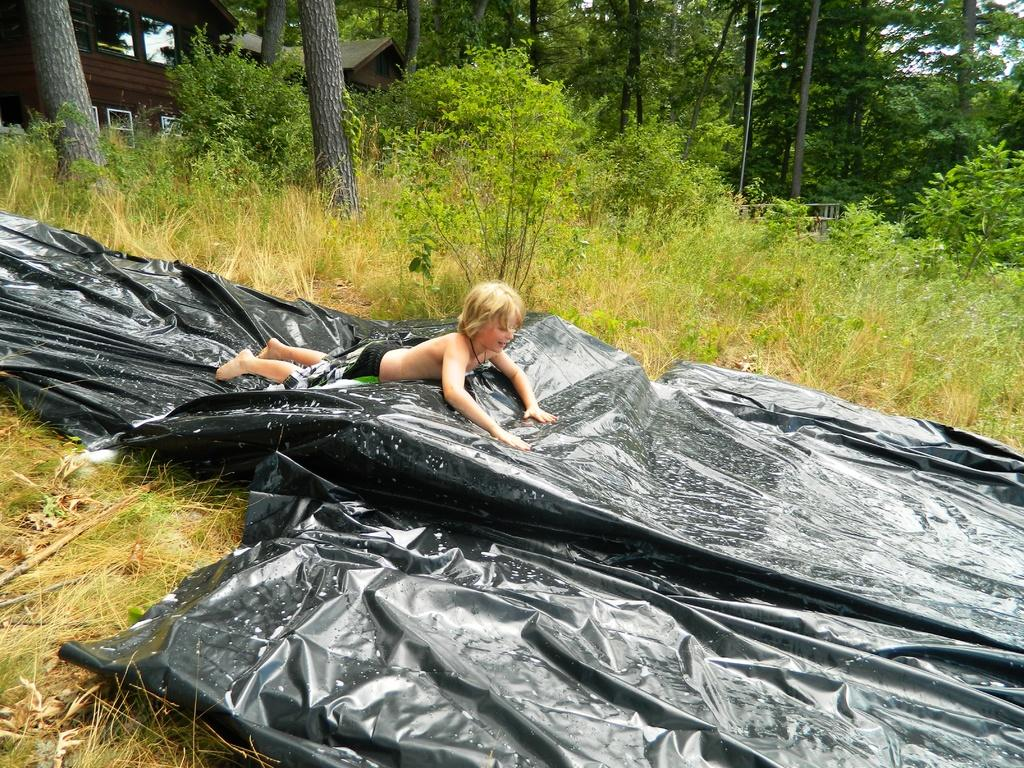What is the boy doing in the image? The boy is lying on a tarpaulin sheet in the image. What can be seen in the distance behind the boy? There are buildings and trees in the background of the image. What is visible above the buildings and trees in the image? The sky is visible in the background of the image. What type of plate is the boy holding in the image? There is no plate visible in the image; the boy is lying on a tarpaulin sheet. 